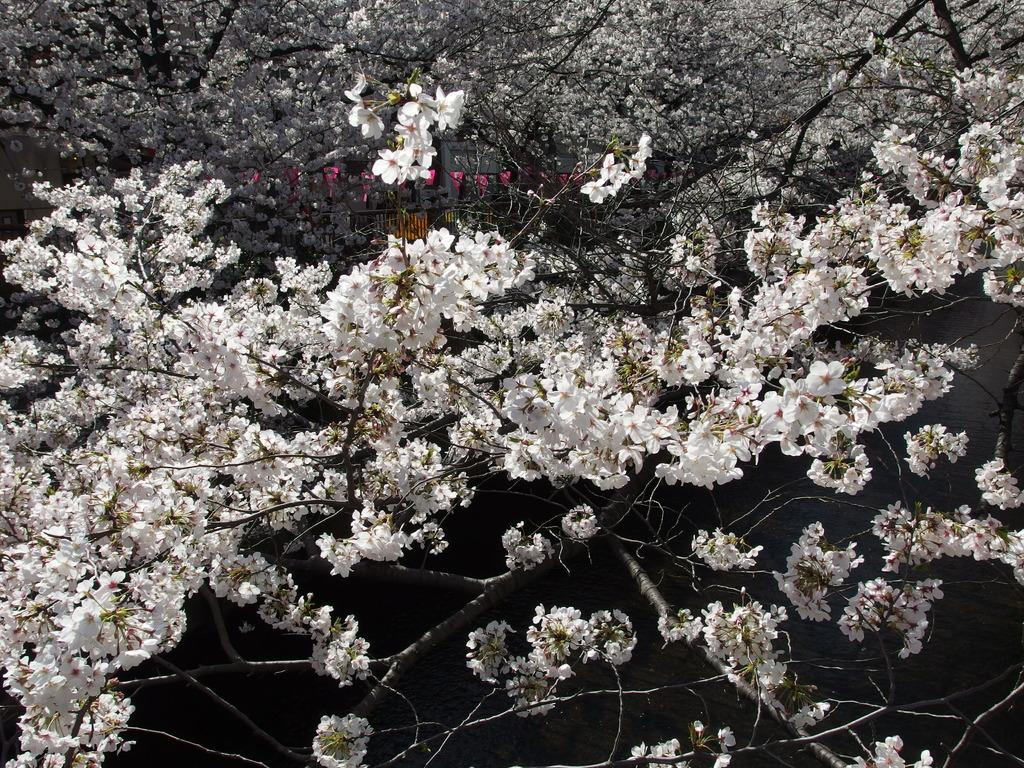What type of vegetation can be seen in the image? There are trees in the image. What color are the flowers on the trees? The flowers on the trees have a white color. What type of sign is visible in the image? There is no sign present in the image; it only features trees with white flowers. What type of stew is being prepared in the image? There is no stew or cooking activity present in the image; it only features trees with white flowers. 